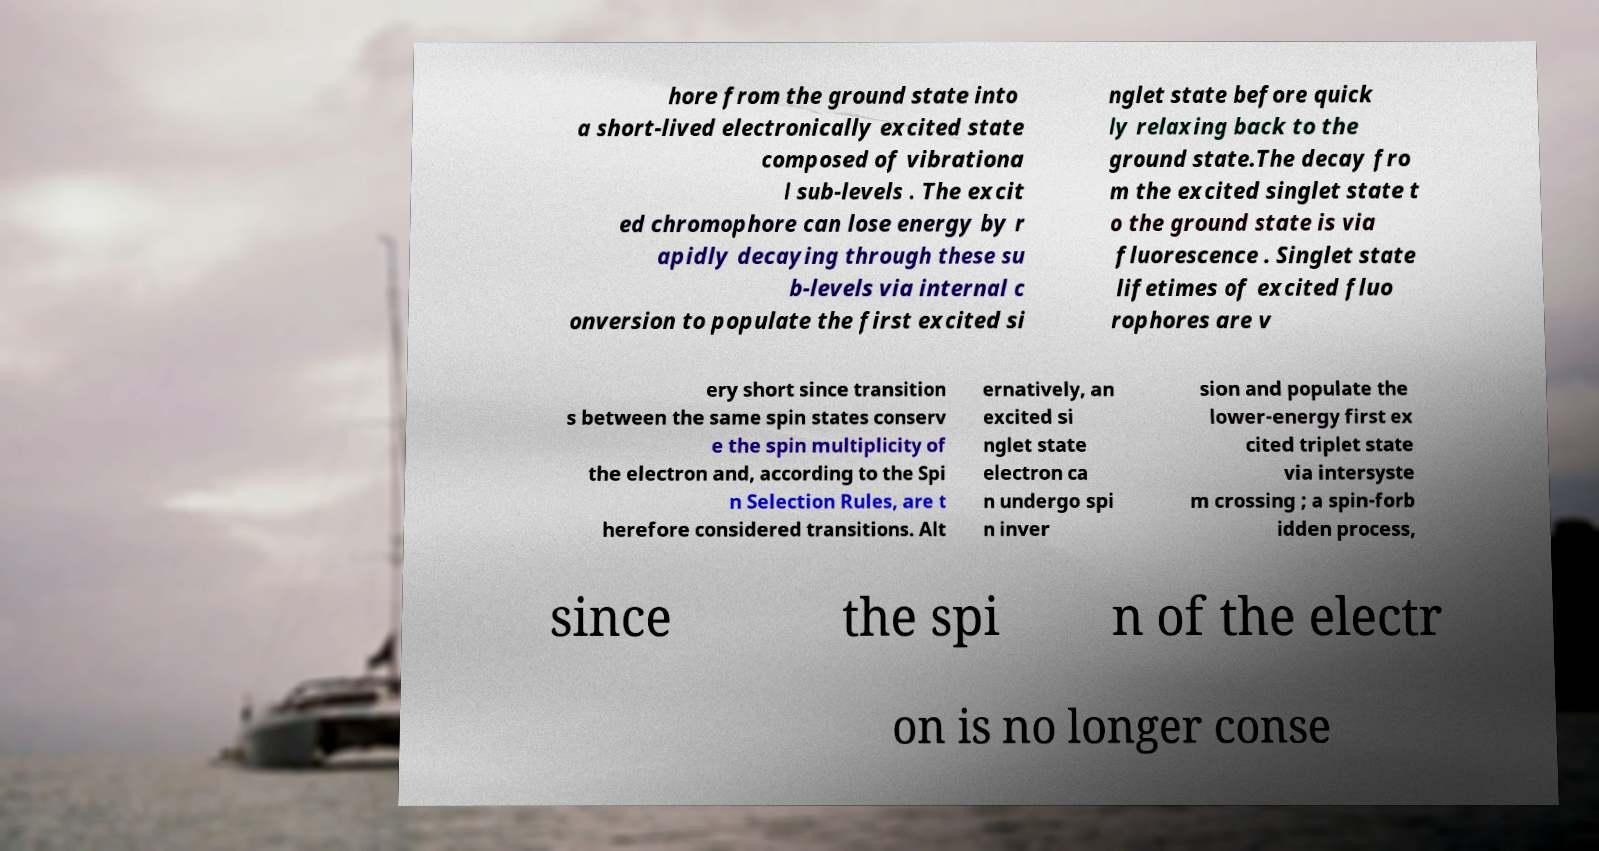Can you read and provide the text displayed in the image?This photo seems to have some interesting text. Can you extract and type it out for me? hore from the ground state into a short-lived electronically excited state composed of vibrationa l sub-levels . The excit ed chromophore can lose energy by r apidly decaying through these su b-levels via internal c onversion to populate the first excited si nglet state before quick ly relaxing back to the ground state.The decay fro m the excited singlet state t o the ground state is via fluorescence . Singlet state lifetimes of excited fluo rophores are v ery short since transition s between the same spin states conserv e the spin multiplicity of the electron and, according to the Spi n Selection Rules, are t herefore considered transitions. Alt ernatively, an excited si nglet state electron ca n undergo spi n inver sion and populate the lower-energy first ex cited triplet state via intersyste m crossing ; a spin-forb idden process, since the spi n of the electr on is no longer conse 